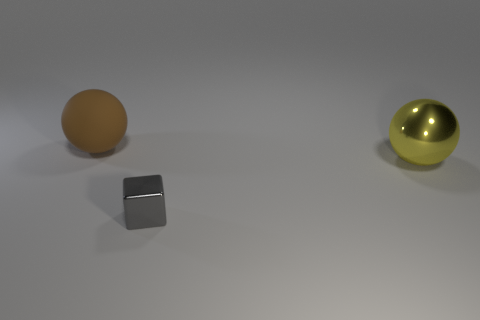Add 3 small gray objects. How many objects exist? 6 Subtract all spheres. How many objects are left? 1 Add 1 metallic blocks. How many metallic blocks are left? 2 Add 3 large purple things. How many large purple things exist? 3 Subtract 0 purple cubes. How many objects are left? 3 Subtract all purple things. Subtract all large things. How many objects are left? 1 